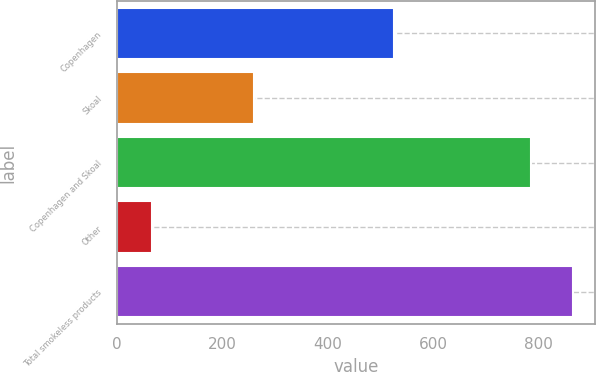<chart> <loc_0><loc_0><loc_500><loc_500><bar_chart><fcel>Copenhagen<fcel>Skoal<fcel>Copenhagen and Skoal<fcel>Other<fcel>Total smokeless products<nl><fcel>525.1<fcel>260.9<fcel>786<fcel>67.5<fcel>864.6<nl></chart> 